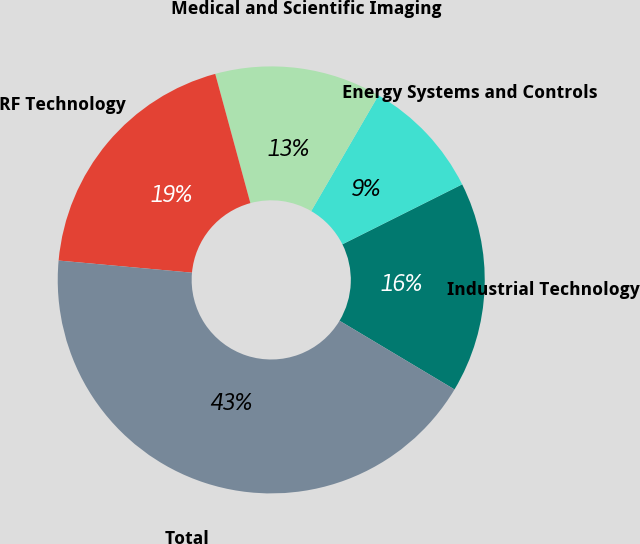Convert chart. <chart><loc_0><loc_0><loc_500><loc_500><pie_chart><fcel>Industrial Technology<fcel>Energy Systems and Controls<fcel>Medical and Scientific Imaging<fcel>RF Technology<fcel>Total<nl><fcel>15.96%<fcel>9.24%<fcel>12.6%<fcel>19.33%<fcel>42.87%<nl></chart> 